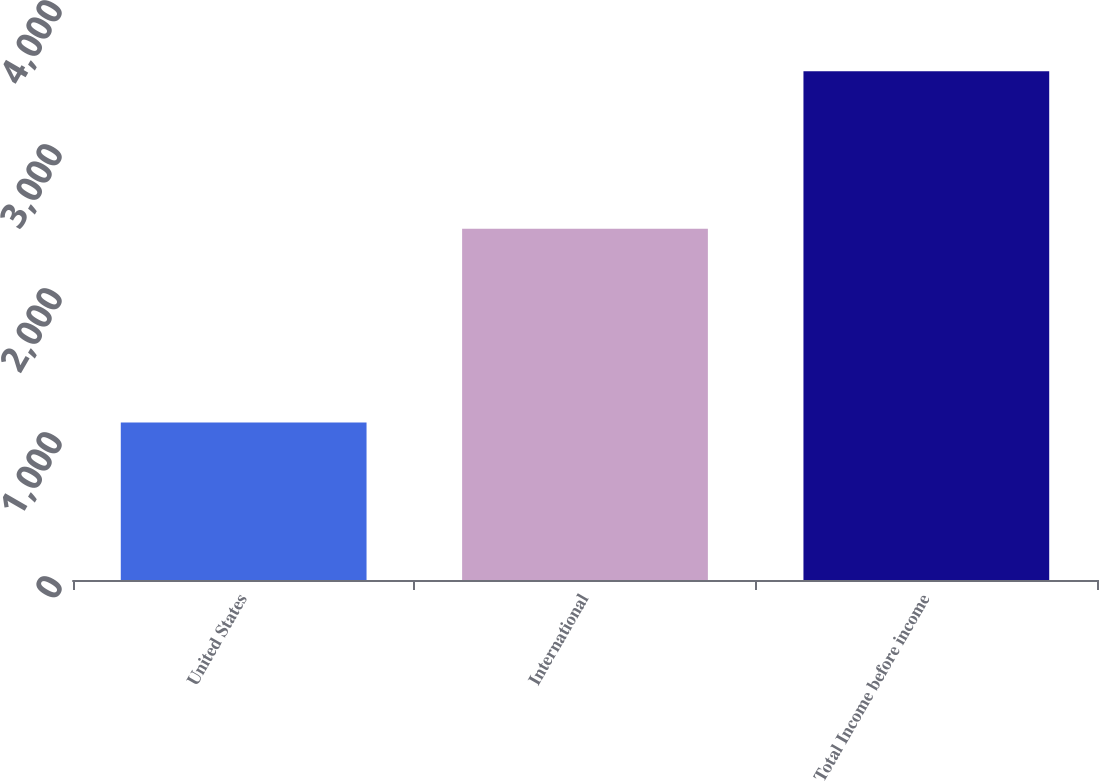Convert chart. <chart><loc_0><loc_0><loc_500><loc_500><bar_chart><fcel>United States<fcel>International<fcel>Total Income before income<nl><fcel>1094<fcel>2439<fcel>3533<nl></chart> 